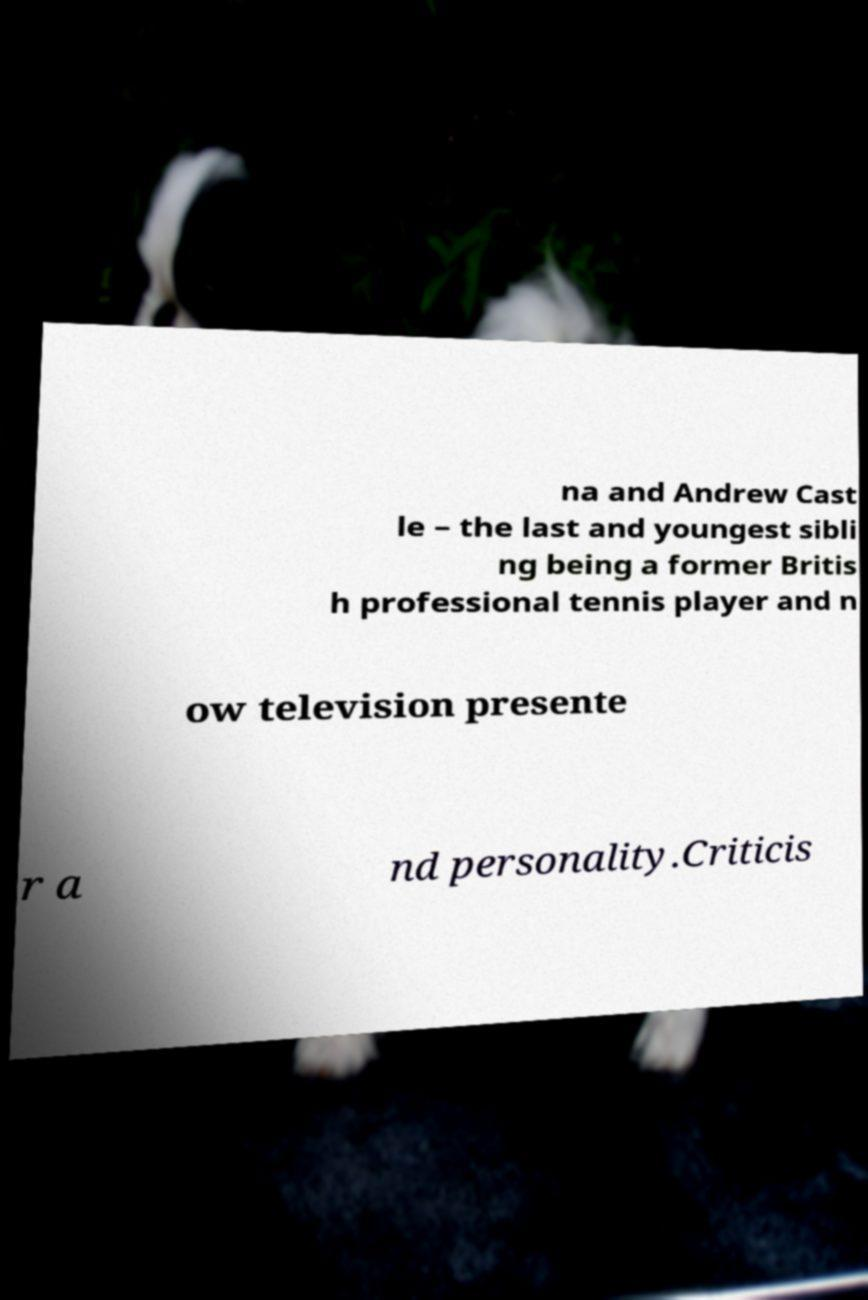Could you extract and type out the text from this image? na and Andrew Cast le – the last and youngest sibli ng being a former Britis h professional tennis player and n ow television presente r a nd personality.Criticis 